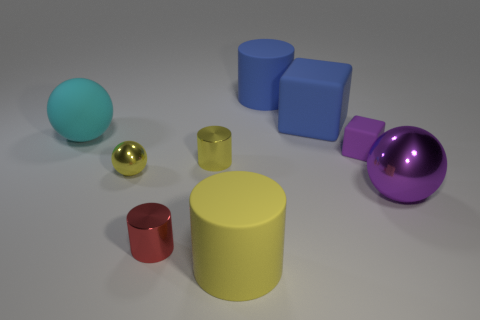Subtract 1 cylinders. How many cylinders are left? 3 Subtract all purple cylinders. Subtract all purple spheres. How many cylinders are left? 4 Add 1 large cyan matte blocks. How many objects exist? 10 Subtract all cubes. How many objects are left? 7 Subtract all big brown shiny cubes. Subtract all large blue things. How many objects are left? 7 Add 6 red cylinders. How many red cylinders are left? 7 Add 2 yellow rubber cylinders. How many yellow rubber cylinders exist? 3 Subtract 0 green cylinders. How many objects are left? 9 